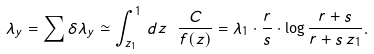<formula> <loc_0><loc_0><loc_500><loc_500>\lambda _ { y } = \sum \delta \lambda _ { y } \simeq \int _ { z _ { 1 } } ^ { 1 } \, d z \ \frac { C } { f ( z ) } = \lambda _ { 1 } \cdot \frac { r } { s } \cdot \log \frac { r + s } { r + s \, z _ { 1 } } .</formula> 